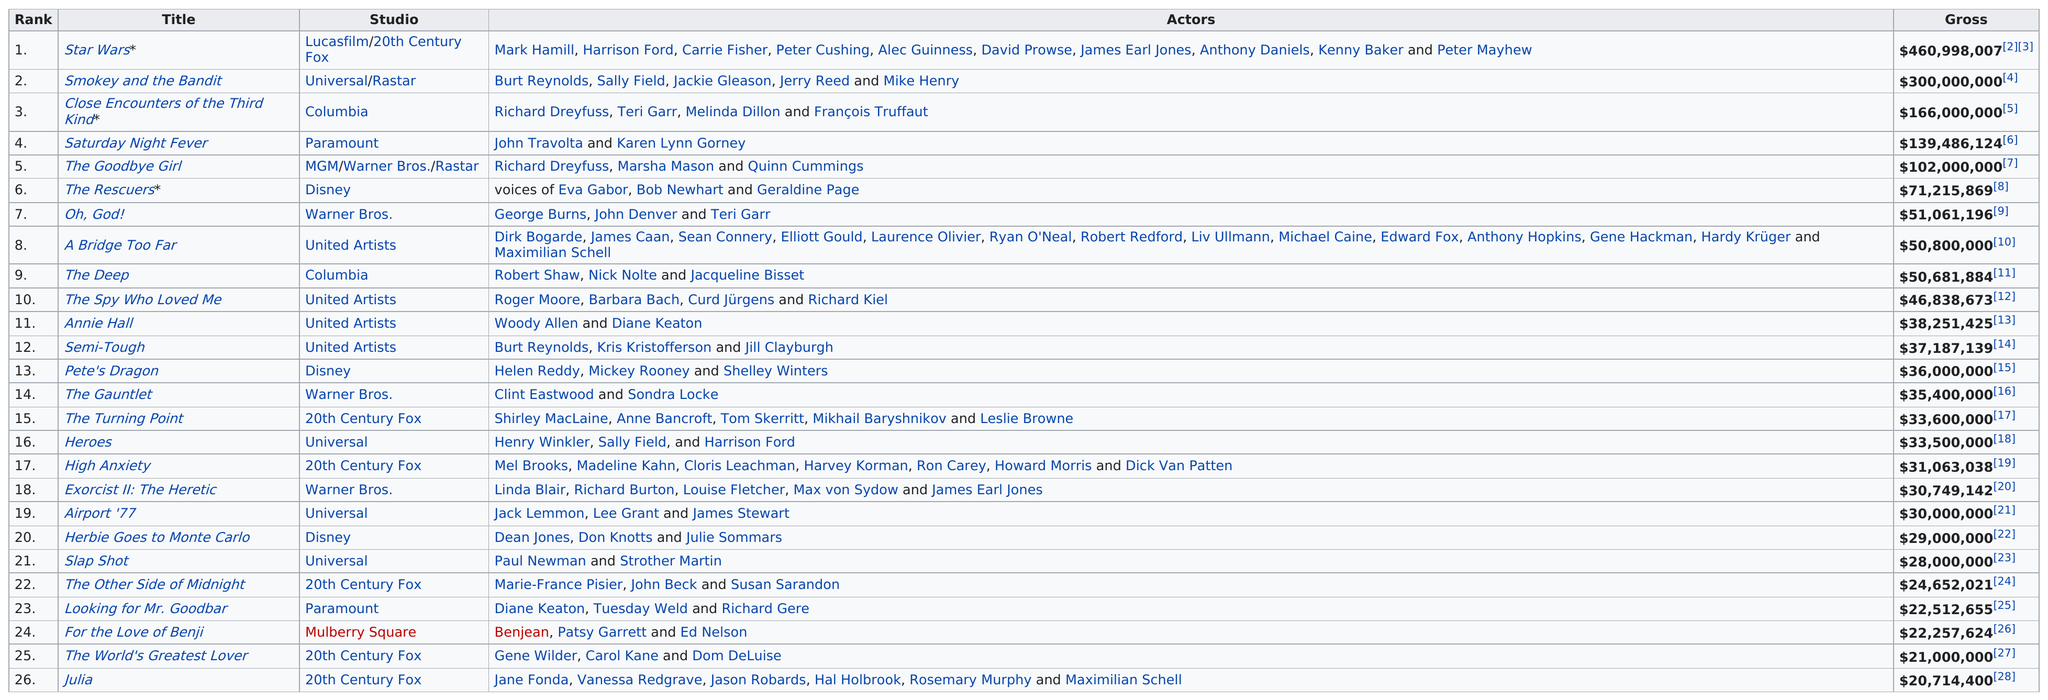Outline some significant characteristics in this image. Annie Hall, a film starring Diane Keaton, ranked higher than which other film? Smokey and the Bandit was the second highest grossing film of 1977. The film that did not gross over $21,000,000 is Julia. In the 26 top grossing films, 20th Century Fox had the most films listed. Of the 26 top-grossing films of 1977, 6 were released by 20th Century Fox. 